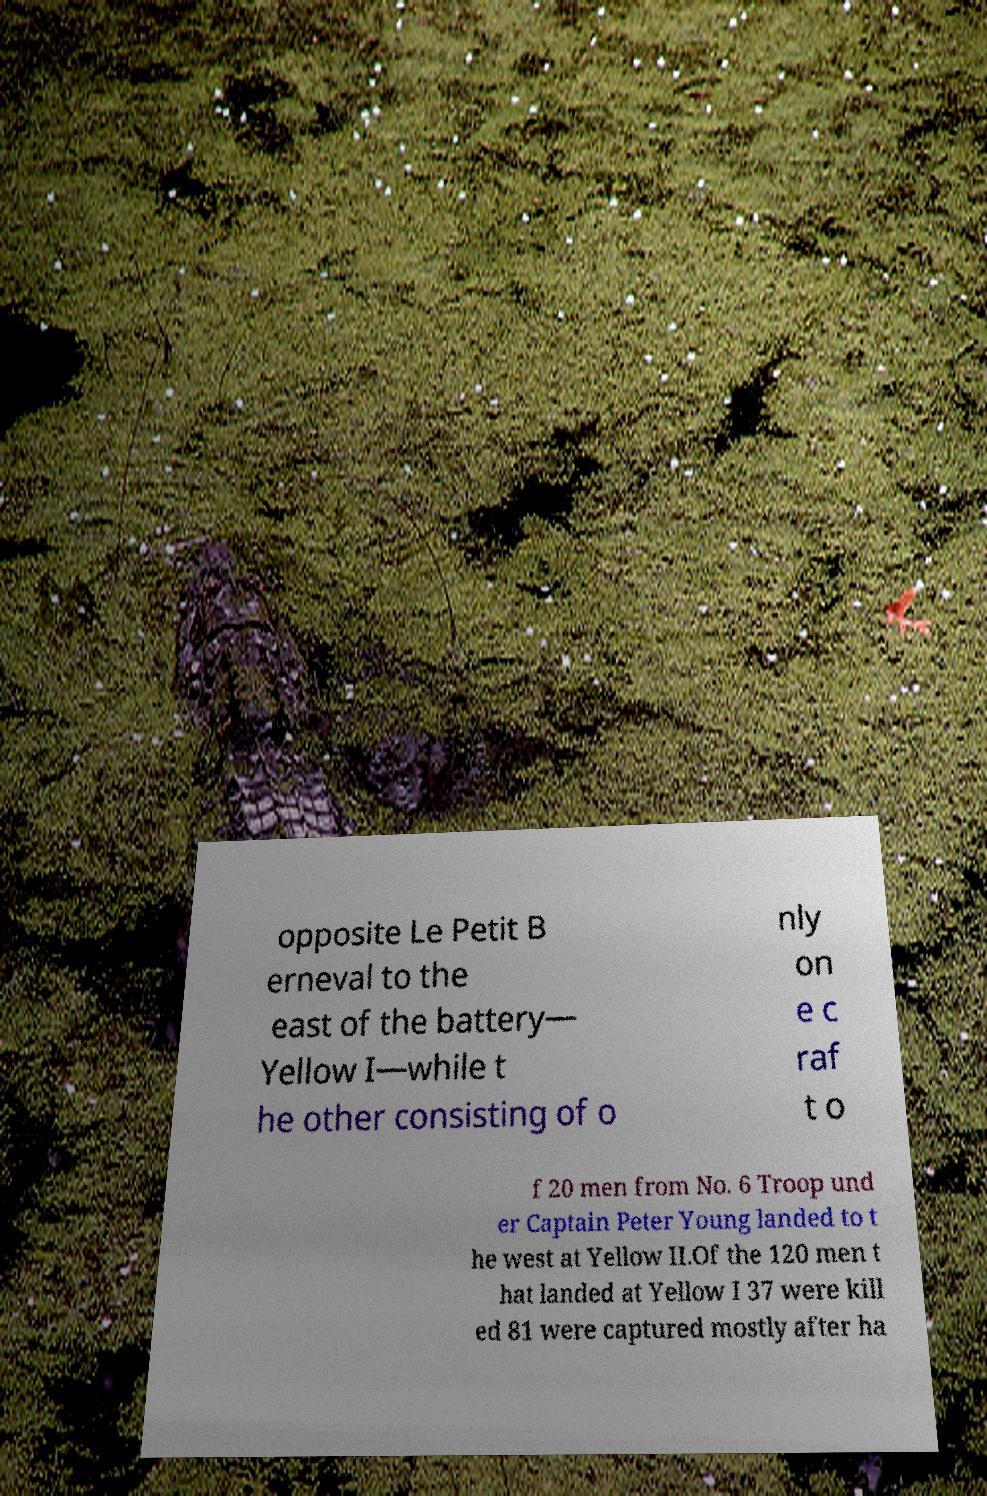Could you assist in decoding the text presented in this image and type it out clearly? opposite Le Petit B erneval to the east of the battery— Yellow I—while t he other consisting of o nly on e c raf t o f 20 men from No. 6 Troop und er Captain Peter Young landed to t he west at Yellow II.Of the 120 men t hat landed at Yellow I 37 were kill ed 81 were captured mostly after ha 